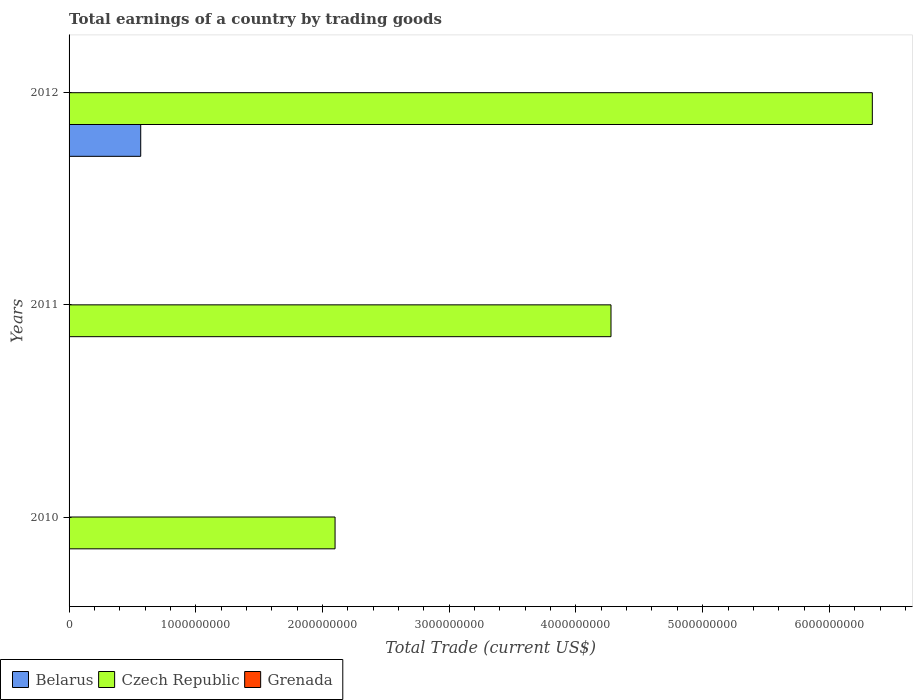How many different coloured bars are there?
Provide a succinct answer. 2. Are the number of bars per tick equal to the number of legend labels?
Make the answer very short. No. How many bars are there on the 2nd tick from the top?
Your response must be concise. 1. In how many cases, is the number of bars for a given year not equal to the number of legend labels?
Ensure brevity in your answer.  3. What is the total earnings in Grenada in 2011?
Provide a short and direct response. 0. Across all years, what is the maximum total earnings in Czech Republic?
Offer a very short reply. 6.34e+09. Across all years, what is the minimum total earnings in Czech Republic?
Provide a succinct answer. 2.10e+09. What is the total total earnings in Czech Republic in the graph?
Your answer should be very brief. 1.27e+1. What is the difference between the total earnings in Czech Republic in 2010 and that in 2012?
Ensure brevity in your answer.  -4.24e+09. What is the difference between the total earnings in Grenada in 2011 and the total earnings in Czech Republic in 2012?
Your answer should be very brief. -6.34e+09. What is the average total earnings in Belarus per year?
Offer a very short reply. 1.88e+08. In the year 2012, what is the difference between the total earnings in Czech Republic and total earnings in Belarus?
Ensure brevity in your answer.  5.77e+09. Is the total earnings in Czech Republic in 2011 less than that in 2012?
Offer a very short reply. Yes. What is the difference between the highest and the second highest total earnings in Czech Republic?
Your response must be concise. 2.06e+09. What is the difference between the highest and the lowest total earnings in Belarus?
Your answer should be very brief. 5.65e+08. In how many years, is the total earnings in Czech Republic greater than the average total earnings in Czech Republic taken over all years?
Offer a very short reply. 2. Does the graph contain any zero values?
Your answer should be very brief. Yes. What is the title of the graph?
Your answer should be compact. Total earnings of a country by trading goods. Does "Portugal" appear as one of the legend labels in the graph?
Offer a terse response. No. What is the label or title of the X-axis?
Your answer should be compact. Total Trade (current US$). What is the Total Trade (current US$) of Czech Republic in 2010?
Keep it short and to the point. 2.10e+09. What is the Total Trade (current US$) in Grenada in 2010?
Keep it short and to the point. 0. What is the Total Trade (current US$) of Czech Republic in 2011?
Offer a terse response. 4.28e+09. What is the Total Trade (current US$) in Belarus in 2012?
Keep it short and to the point. 5.65e+08. What is the Total Trade (current US$) of Czech Republic in 2012?
Offer a terse response. 6.34e+09. Across all years, what is the maximum Total Trade (current US$) of Belarus?
Make the answer very short. 5.65e+08. Across all years, what is the maximum Total Trade (current US$) of Czech Republic?
Give a very brief answer. 6.34e+09. Across all years, what is the minimum Total Trade (current US$) of Czech Republic?
Keep it short and to the point. 2.10e+09. What is the total Total Trade (current US$) of Belarus in the graph?
Offer a very short reply. 5.65e+08. What is the total Total Trade (current US$) of Czech Republic in the graph?
Provide a short and direct response. 1.27e+1. What is the difference between the Total Trade (current US$) in Czech Republic in 2010 and that in 2011?
Your answer should be very brief. -2.18e+09. What is the difference between the Total Trade (current US$) of Czech Republic in 2010 and that in 2012?
Provide a succinct answer. -4.24e+09. What is the difference between the Total Trade (current US$) of Czech Republic in 2011 and that in 2012?
Ensure brevity in your answer.  -2.06e+09. What is the average Total Trade (current US$) of Belarus per year?
Give a very brief answer. 1.88e+08. What is the average Total Trade (current US$) in Czech Republic per year?
Keep it short and to the point. 4.24e+09. What is the average Total Trade (current US$) of Grenada per year?
Make the answer very short. 0. In the year 2012, what is the difference between the Total Trade (current US$) in Belarus and Total Trade (current US$) in Czech Republic?
Your answer should be compact. -5.77e+09. What is the ratio of the Total Trade (current US$) of Czech Republic in 2010 to that in 2011?
Make the answer very short. 0.49. What is the ratio of the Total Trade (current US$) of Czech Republic in 2010 to that in 2012?
Make the answer very short. 0.33. What is the ratio of the Total Trade (current US$) of Czech Republic in 2011 to that in 2012?
Provide a succinct answer. 0.67. What is the difference between the highest and the second highest Total Trade (current US$) of Czech Republic?
Give a very brief answer. 2.06e+09. What is the difference between the highest and the lowest Total Trade (current US$) in Belarus?
Make the answer very short. 5.65e+08. What is the difference between the highest and the lowest Total Trade (current US$) of Czech Republic?
Your answer should be very brief. 4.24e+09. 